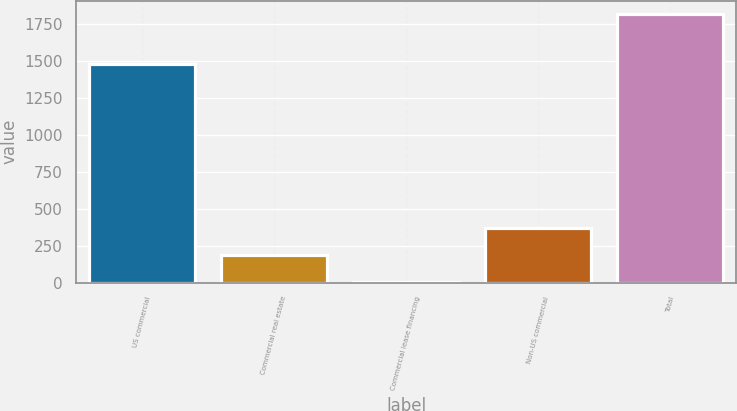Convert chart to OTSL. <chart><loc_0><loc_0><loc_500><loc_500><bar_chart><fcel>US commercial<fcel>Commercial real estate<fcel>Commercial lease financing<fcel>Non-US commercial<fcel>Total<nl><fcel>1482<fcel>185.3<fcel>4<fcel>366.6<fcel>1817<nl></chart> 